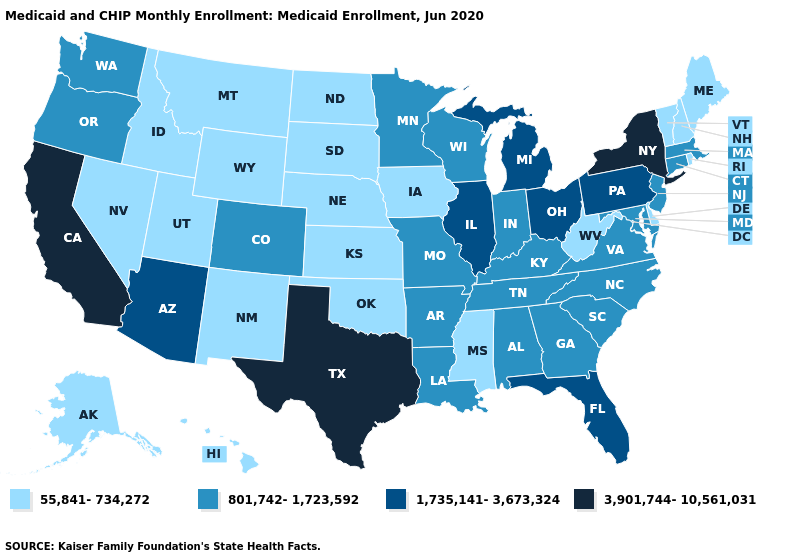Does Tennessee have the lowest value in the South?
Keep it brief. No. What is the value of Maine?
Keep it brief. 55,841-734,272. Does New York have the same value as Tennessee?
Short answer required. No. Among the states that border Kansas , does Oklahoma have the lowest value?
Keep it brief. Yes. What is the highest value in states that border Connecticut?
Answer briefly. 3,901,744-10,561,031. How many symbols are there in the legend?
Be succinct. 4. What is the value of Missouri?
Quick response, please. 801,742-1,723,592. Which states hav the highest value in the Northeast?
Short answer required. New York. Name the states that have a value in the range 1,735,141-3,673,324?
Write a very short answer. Arizona, Florida, Illinois, Michigan, Ohio, Pennsylvania. What is the value of Louisiana?
Be succinct. 801,742-1,723,592. How many symbols are there in the legend?
Concise answer only. 4. Does Illinois have a higher value than Michigan?
Answer briefly. No. Does California have the highest value in the West?
Concise answer only. Yes. Which states have the lowest value in the USA?
Answer briefly. Alaska, Delaware, Hawaii, Idaho, Iowa, Kansas, Maine, Mississippi, Montana, Nebraska, Nevada, New Hampshire, New Mexico, North Dakota, Oklahoma, Rhode Island, South Dakota, Utah, Vermont, West Virginia, Wyoming. 